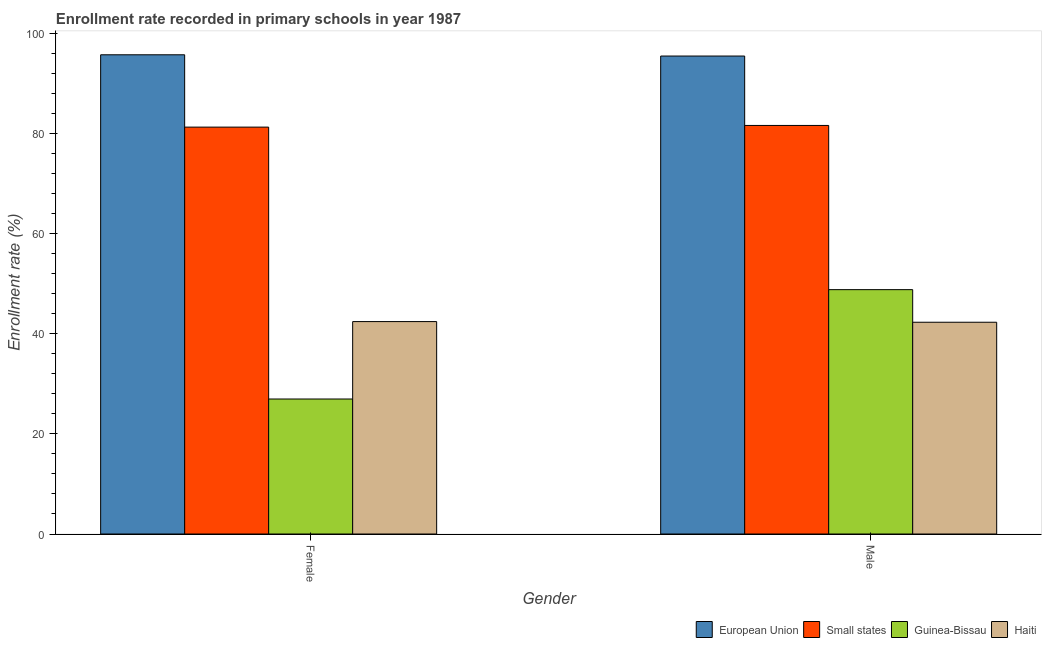How many bars are there on the 2nd tick from the left?
Provide a succinct answer. 4. How many bars are there on the 2nd tick from the right?
Your response must be concise. 4. What is the label of the 2nd group of bars from the left?
Ensure brevity in your answer.  Male. What is the enrollment rate of female students in Guinea-Bissau?
Your response must be concise. 26.96. Across all countries, what is the maximum enrollment rate of male students?
Provide a succinct answer. 95.44. Across all countries, what is the minimum enrollment rate of male students?
Provide a succinct answer. 42.28. In which country was the enrollment rate of female students minimum?
Your response must be concise. Guinea-Bissau. What is the total enrollment rate of female students in the graph?
Your answer should be very brief. 246.31. What is the difference between the enrollment rate of female students in Guinea-Bissau and that in Small states?
Give a very brief answer. -54.29. What is the difference between the enrollment rate of male students in Guinea-Bissau and the enrollment rate of female students in Haiti?
Make the answer very short. 6.38. What is the average enrollment rate of male students per country?
Make the answer very short. 67.02. What is the difference between the enrollment rate of male students and enrollment rate of female students in European Union?
Ensure brevity in your answer.  -0.25. What is the ratio of the enrollment rate of female students in Small states to that in European Union?
Keep it short and to the point. 0.85. In how many countries, is the enrollment rate of male students greater than the average enrollment rate of male students taken over all countries?
Make the answer very short. 2. What does the 4th bar from the left in Female represents?
Offer a terse response. Haiti. What does the 4th bar from the right in Female represents?
Your answer should be very brief. European Union. How many bars are there?
Make the answer very short. 8. Are all the bars in the graph horizontal?
Offer a very short reply. No. Are the values on the major ticks of Y-axis written in scientific E-notation?
Your answer should be compact. No. Does the graph contain any zero values?
Your answer should be very brief. No. Does the graph contain grids?
Provide a succinct answer. No. How many legend labels are there?
Make the answer very short. 4. How are the legend labels stacked?
Provide a short and direct response. Horizontal. What is the title of the graph?
Your answer should be compact. Enrollment rate recorded in primary schools in year 1987. What is the label or title of the Y-axis?
Ensure brevity in your answer.  Enrollment rate (%). What is the Enrollment rate (%) in European Union in Female?
Your answer should be compact. 95.69. What is the Enrollment rate (%) in Small states in Female?
Offer a terse response. 81.25. What is the Enrollment rate (%) in Guinea-Bissau in Female?
Provide a succinct answer. 26.96. What is the Enrollment rate (%) of Haiti in Female?
Keep it short and to the point. 42.42. What is the Enrollment rate (%) of European Union in Male?
Provide a short and direct response. 95.44. What is the Enrollment rate (%) of Small states in Male?
Offer a very short reply. 81.58. What is the Enrollment rate (%) in Guinea-Bissau in Male?
Keep it short and to the point. 48.79. What is the Enrollment rate (%) of Haiti in Male?
Your answer should be very brief. 42.28. Across all Gender, what is the maximum Enrollment rate (%) in European Union?
Provide a succinct answer. 95.69. Across all Gender, what is the maximum Enrollment rate (%) in Small states?
Your answer should be very brief. 81.58. Across all Gender, what is the maximum Enrollment rate (%) in Guinea-Bissau?
Offer a very short reply. 48.79. Across all Gender, what is the maximum Enrollment rate (%) of Haiti?
Your response must be concise. 42.42. Across all Gender, what is the minimum Enrollment rate (%) in European Union?
Provide a short and direct response. 95.44. Across all Gender, what is the minimum Enrollment rate (%) of Small states?
Give a very brief answer. 81.25. Across all Gender, what is the minimum Enrollment rate (%) of Guinea-Bissau?
Provide a succinct answer. 26.96. Across all Gender, what is the minimum Enrollment rate (%) in Haiti?
Offer a terse response. 42.28. What is the total Enrollment rate (%) of European Union in the graph?
Your response must be concise. 191.13. What is the total Enrollment rate (%) in Small states in the graph?
Your answer should be compact. 162.83. What is the total Enrollment rate (%) of Guinea-Bissau in the graph?
Ensure brevity in your answer.  75.75. What is the total Enrollment rate (%) of Haiti in the graph?
Provide a succinct answer. 84.7. What is the difference between the Enrollment rate (%) in European Union in Female and that in Male?
Your answer should be very brief. 0.25. What is the difference between the Enrollment rate (%) in Small states in Female and that in Male?
Your answer should be compact. -0.34. What is the difference between the Enrollment rate (%) in Guinea-Bissau in Female and that in Male?
Make the answer very short. -21.84. What is the difference between the Enrollment rate (%) in Haiti in Female and that in Male?
Your answer should be compact. 0.13. What is the difference between the Enrollment rate (%) of European Union in Female and the Enrollment rate (%) of Small states in Male?
Provide a succinct answer. 14.11. What is the difference between the Enrollment rate (%) of European Union in Female and the Enrollment rate (%) of Guinea-Bissau in Male?
Provide a short and direct response. 46.9. What is the difference between the Enrollment rate (%) of European Union in Female and the Enrollment rate (%) of Haiti in Male?
Give a very brief answer. 53.41. What is the difference between the Enrollment rate (%) in Small states in Female and the Enrollment rate (%) in Guinea-Bissau in Male?
Your response must be concise. 32.46. What is the difference between the Enrollment rate (%) in Small states in Female and the Enrollment rate (%) in Haiti in Male?
Ensure brevity in your answer.  38.96. What is the difference between the Enrollment rate (%) of Guinea-Bissau in Female and the Enrollment rate (%) of Haiti in Male?
Provide a succinct answer. -15.33. What is the average Enrollment rate (%) in European Union per Gender?
Ensure brevity in your answer.  95.57. What is the average Enrollment rate (%) in Small states per Gender?
Offer a terse response. 81.42. What is the average Enrollment rate (%) in Guinea-Bissau per Gender?
Ensure brevity in your answer.  37.87. What is the average Enrollment rate (%) in Haiti per Gender?
Provide a short and direct response. 42.35. What is the difference between the Enrollment rate (%) in European Union and Enrollment rate (%) in Small states in Female?
Offer a terse response. 14.44. What is the difference between the Enrollment rate (%) of European Union and Enrollment rate (%) of Guinea-Bissau in Female?
Your answer should be compact. 68.74. What is the difference between the Enrollment rate (%) in European Union and Enrollment rate (%) in Haiti in Female?
Offer a very short reply. 53.27. What is the difference between the Enrollment rate (%) in Small states and Enrollment rate (%) in Guinea-Bissau in Female?
Keep it short and to the point. 54.29. What is the difference between the Enrollment rate (%) of Small states and Enrollment rate (%) of Haiti in Female?
Keep it short and to the point. 38.83. What is the difference between the Enrollment rate (%) in Guinea-Bissau and Enrollment rate (%) in Haiti in Female?
Give a very brief answer. -15.46. What is the difference between the Enrollment rate (%) in European Union and Enrollment rate (%) in Small states in Male?
Keep it short and to the point. 13.86. What is the difference between the Enrollment rate (%) in European Union and Enrollment rate (%) in Guinea-Bissau in Male?
Make the answer very short. 46.65. What is the difference between the Enrollment rate (%) of European Union and Enrollment rate (%) of Haiti in Male?
Ensure brevity in your answer.  53.16. What is the difference between the Enrollment rate (%) of Small states and Enrollment rate (%) of Guinea-Bissau in Male?
Give a very brief answer. 32.79. What is the difference between the Enrollment rate (%) of Small states and Enrollment rate (%) of Haiti in Male?
Your answer should be very brief. 39.3. What is the difference between the Enrollment rate (%) in Guinea-Bissau and Enrollment rate (%) in Haiti in Male?
Ensure brevity in your answer.  6.51. What is the ratio of the Enrollment rate (%) of European Union in Female to that in Male?
Your answer should be compact. 1. What is the ratio of the Enrollment rate (%) in Guinea-Bissau in Female to that in Male?
Keep it short and to the point. 0.55. What is the ratio of the Enrollment rate (%) in Haiti in Female to that in Male?
Your answer should be very brief. 1. What is the difference between the highest and the second highest Enrollment rate (%) in European Union?
Keep it short and to the point. 0.25. What is the difference between the highest and the second highest Enrollment rate (%) of Small states?
Provide a succinct answer. 0.34. What is the difference between the highest and the second highest Enrollment rate (%) of Guinea-Bissau?
Provide a short and direct response. 21.84. What is the difference between the highest and the second highest Enrollment rate (%) in Haiti?
Offer a terse response. 0.13. What is the difference between the highest and the lowest Enrollment rate (%) in European Union?
Your answer should be compact. 0.25. What is the difference between the highest and the lowest Enrollment rate (%) in Small states?
Make the answer very short. 0.34. What is the difference between the highest and the lowest Enrollment rate (%) in Guinea-Bissau?
Your answer should be very brief. 21.84. What is the difference between the highest and the lowest Enrollment rate (%) in Haiti?
Ensure brevity in your answer.  0.13. 